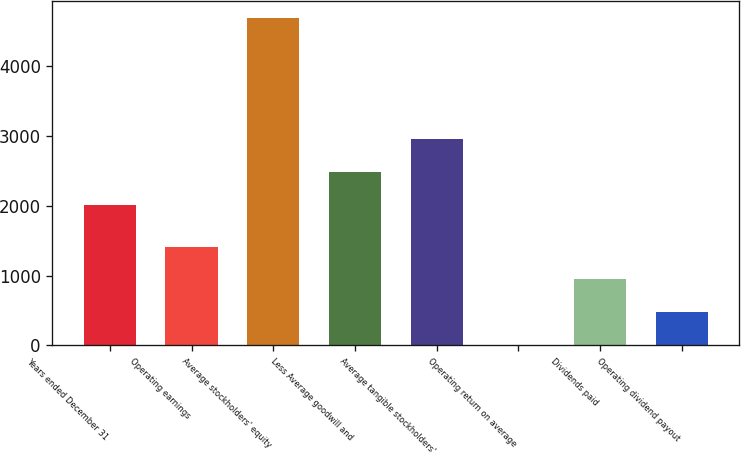Convert chart to OTSL. <chart><loc_0><loc_0><loc_500><loc_500><bar_chart><fcel>Years ended December 31<fcel>Operating earnings<fcel>Average stockholders' equity<fcel>Less Average goodwill and<fcel>Average tangible stockholders'<fcel>Operating return on average<fcel>Dividends paid<fcel>Operating dividend payout<nl><fcel>2015<fcel>1416.17<fcel>4697<fcel>2483.69<fcel>2952.38<fcel>10.1<fcel>947.48<fcel>478.79<nl></chart> 